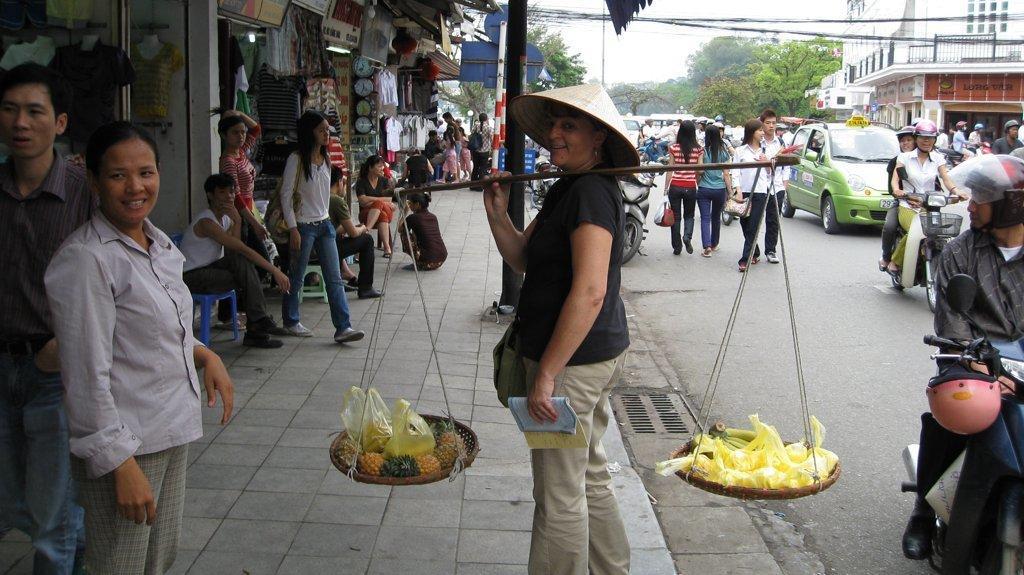In one or two sentences, can you explain what this image depicts? In this image there are people. The person standing in the center is holding a balancing stick and there are some objects in the baskets. In the background there are buildings, trees and sky. There are wires and we can see vehicles on the road. There are stores. 